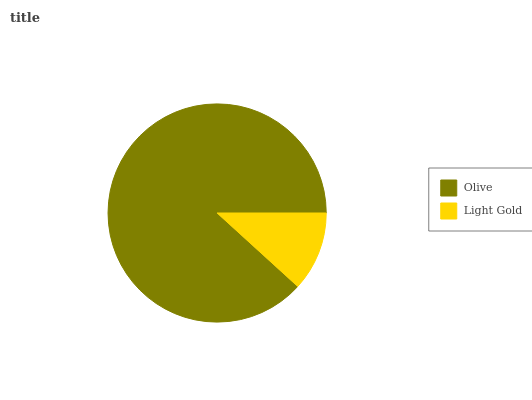Is Light Gold the minimum?
Answer yes or no. Yes. Is Olive the maximum?
Answer yes or no. Yes. Is Light Gold the maximum?
Answer yes or no. No. Is Olive greater than Light Gold?
Answer yes or no. Yes. Is Light Gold less than Olive?
Answer yes or no. Yes. Is Light Gold greater than Olive?
Answer yes or no. No. Is Olive less than Light Gold?
Answer yes or no. No. Is Olive the high median?
Answer yes or no. Yes. Is Light Gold the low median?
Answer yes or no. Yes. Is Light Gold the high median?
Answer yes or no. No. Is Olive the low median?
Answer yes or no. No. 